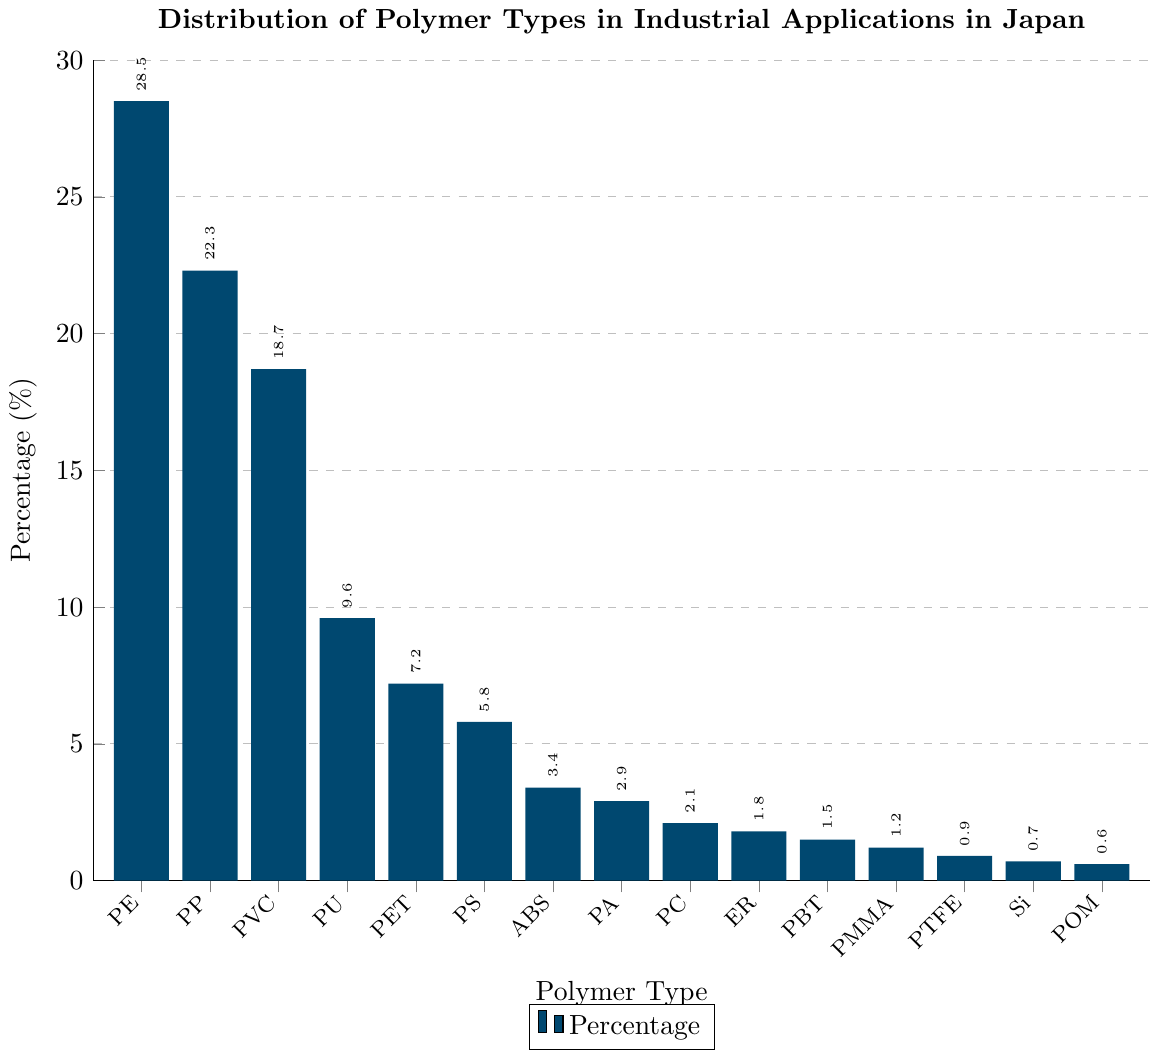Which polymer type has the highest percentage in industrial applications in Japan? The bar chart shows the distribution of polymer types, and the tallest bar represents the highest percentage. The tallest bar is for Polyethylene (PE) at 28.5%.
Answer: Polyethylene (PE) Which two polymer types have percentages that sum up to approximately 50%? By visually inspecting the chart, the percentages for Polyethylene (28.5%) and Polypropylene (22.3%) add up to 50.8%.
Answer: Polyethylene (PE) and Polypropylene (PP) Is the percentage of Polyoxymethylene (POM) higher than that of Silicone (Si)? By comparing the heights of the bars labeled Si and POM, POM has a percentage of 0.6%, and Silicone has 0.7%.
Answer: No What is the difference in percentage between Polyvinyl Chloride (PVC) and Polystyrene (PS)? By reading the values from the bars, PVC is 18.7% and PS is 5.8%. The difference is 18.7% - 5.8% = 12.9%.
Answer: 12.9% Which polymer type has the smallest percentage in industrial applications? The shortest bar on the chart represents the smallest percentage, which corresponds to Polyoxymethylene (POM) at 0.6%.
Answer: Polyoxymethylene (POM) How much higher is the percentage of Polyurethane (PU) compared to that of Polycarbonate (PC)? The percentage for PU is 9.6%, and for PC it is 2.1%. The difference is 9.6% - 2.1% = 7.5%.
Answer: 7.5% Which three polymer types combined have nearly the same percentage as Polypropylene (PP)? By selecting combinations, Polyvinyl Chloride (PVC) 18.7%, Polyurethane (PU) 9.6%, and Polyethylene Terephthalate (PET) 7.2% sum up to 35.5%, nearest to Polypropylene’s 22.3%.
Answer: PVC, PU, and PET How many polymer types have a percentage lower than 5%? By counting the bars with percentages below 5%, we find ABS (3.4%), PA (2.9%), PC (2.1%), ER (1.8%), PBT (1.5%), PMMA (1.2%), PTFE (0.9%), Si (0.7%), and POM (0.6%) totaling 9 polymer types.
Answer: 9 